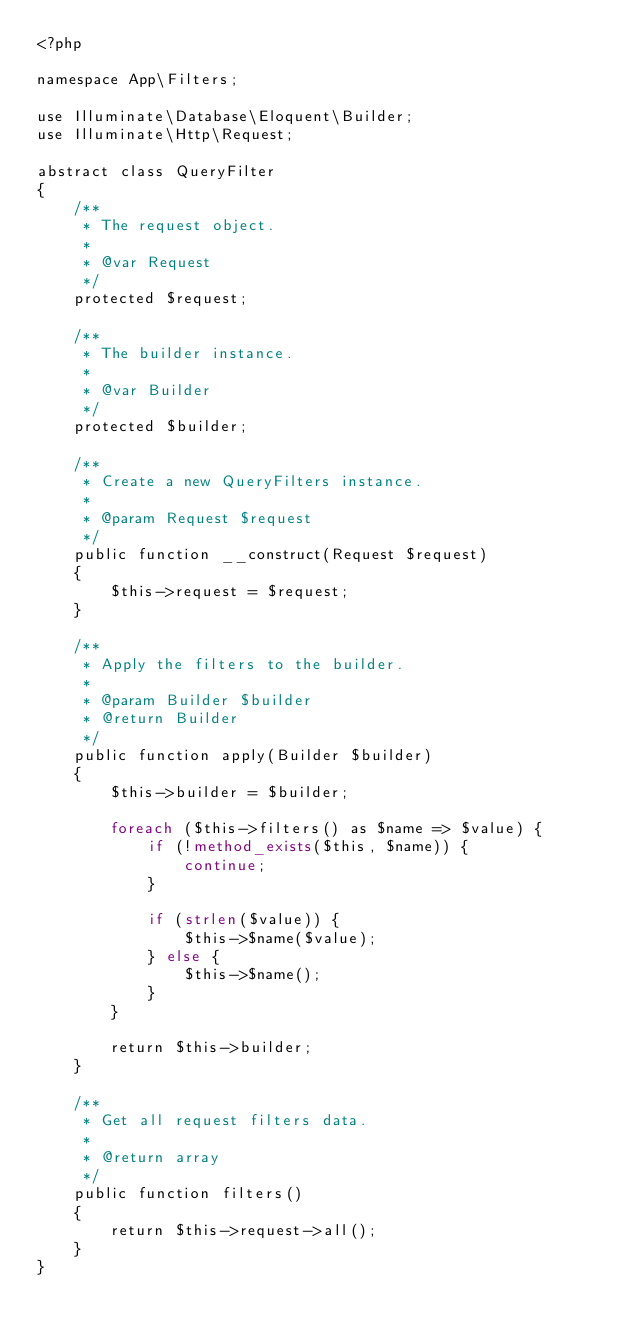<code> <loc_0><loc_0><loc_500><loc_500><_PHP_><?php

namespace App\Filters;

use Illuminate\Database\Eloquent\Builder;
use Illuminate\Http\Request;

abstract class QueryFilter
{
    /**
     * The request object.
     *
     * @var Request
     */
    protected $request;

    /**
     * The builder instance.
     *
     * @var Builder
     */
    protected $builder;

    /**
     * Create a new QueryFilters instance.
     *
     * @param Request $request
     */
    public function __construct(Request $request)
    {
        $this->request = $request;
    }

    /**
     * Apply the filters to the builder.
     *
     * @param Builder $builder
     * @return Builder
     */
    public function apply(Builder $builder)
    {
        $this->builder = $builder;

        foreach ($this->filters() as $name => $value) {
            if (!method_exists($this, $name)) {
                continue;
            }

            if (strlen($value)) {
                $this->$name($value);
            } else {
                $this->$name();
            }
        }

        return $this->builder;
    }

    /**
     * Get all request filters data.
     *
     * @return array
     */
    public function filters()
    {
        return $this->request->all();
    }
}
</code> 